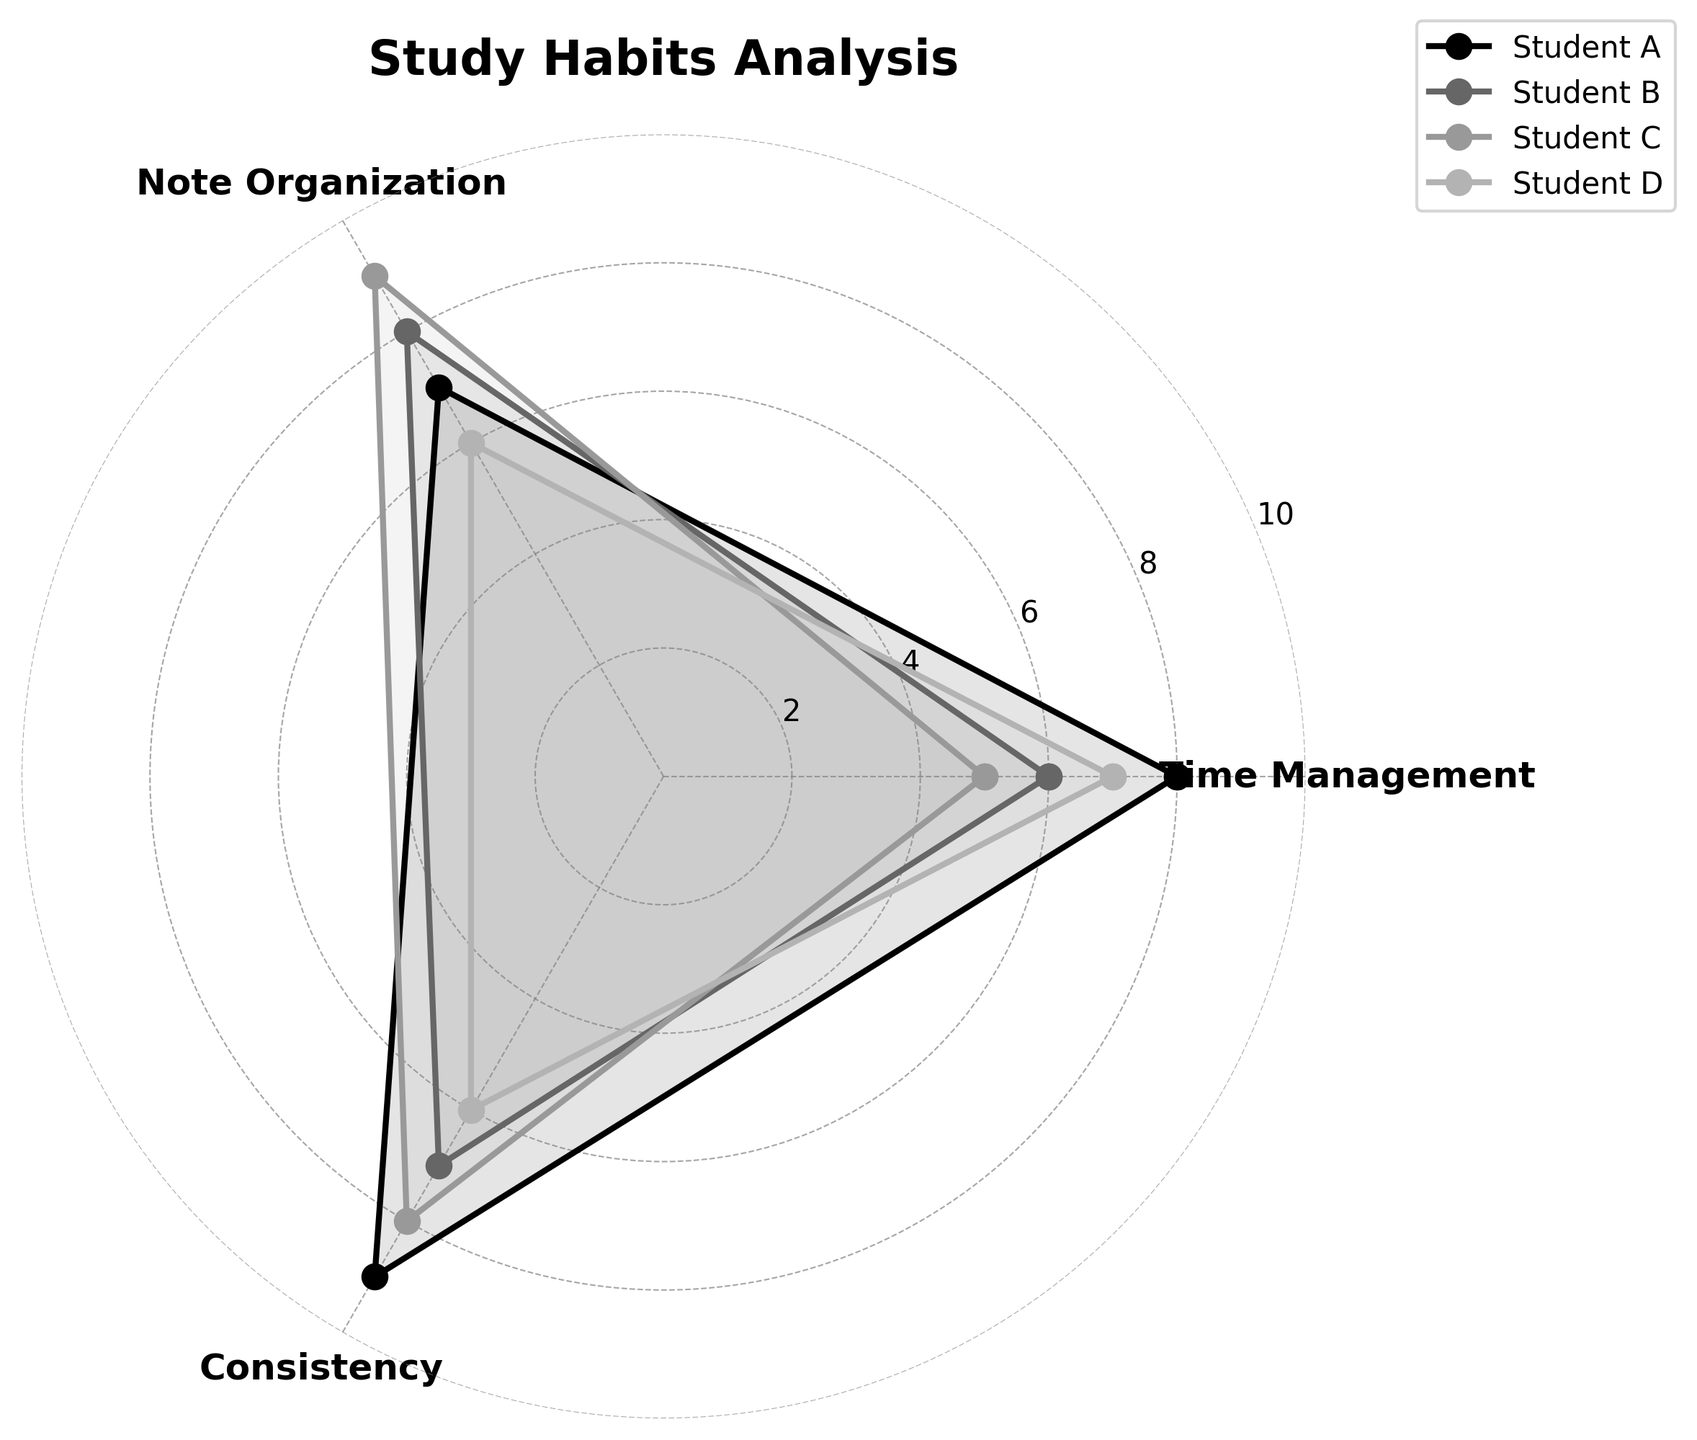What's the title of the radar chart? The title is displayed at the top of the radar chart. It reads "Study Habits Analysis" in bold font.
Answer: Study Habits Analysis What are the three key focus areas shown in the radar chart? The radar chart has three labeled axes representing the key focus areas: "Time Management," "Note Organization," and "Consistency."
Answer: Time Management, Note Organization, Consistency Which student scored the highest in Note Organization? By looking at the axis labeled "Note Organization," we can identify the highest point, which corresponds to Student C with a score of 9.
Answer: Student C How does Student A's score in Time Management compare to Student B's? Student A has a score of 8 in Time Management, while Student B has a score of 6. Thus, Student A's score is higher.
Answer: Student A has a higher score Which student has the most consistent scores across all focus areas? Student A has scores of 8, 7, and 9. Student B has scores of 6, 8, and 7. Student C has scores of 5, 9, and 8. Student D has scores of 7, 6, and 6. Student C’s scores are closest together: 5, 9, 8; therefore, Student C is the most consistent.
Answer: Student C What's the average score for Student D? Student D's scores are 7, 6, and 6. To find the average, sum the scores and divide by the number of focus areas: (7 + 6 + 6) / 3 = 19 / 3 = 6.33.
Answer: 6.33 Between Time Management and Consistency, which area has more variation among students? Time Management scores are 8, 6, 5, and 7. Consistency scores are 9, 7, 8, and 6. Calculating the range (maximum score minus minimum score): Time Management variation is 8 - 5 = 3, Consistency variation is 9 - 6 = 3. Both areas have equal variation.
Answer: Equal variation Which student shows the largest improvement in any one area compared to their other areas? Looking at each student's scores: Student A (8, 7, 9) shows minimal variation. Student B (6, 8, 7) has an improvement of 2 in Note Organization. Student C (5, 9, 8) has a big jump in Note Organization. Student D (7, 6, 6) has less variation. Student C shows the largest improvement by 4 points in Note Organization.
Answer: Student C Who has the lowest score in Consistency? By examining the Consistency axis, the lowest score is 6, held by Students D and A.
Answer: Student D and Student A 